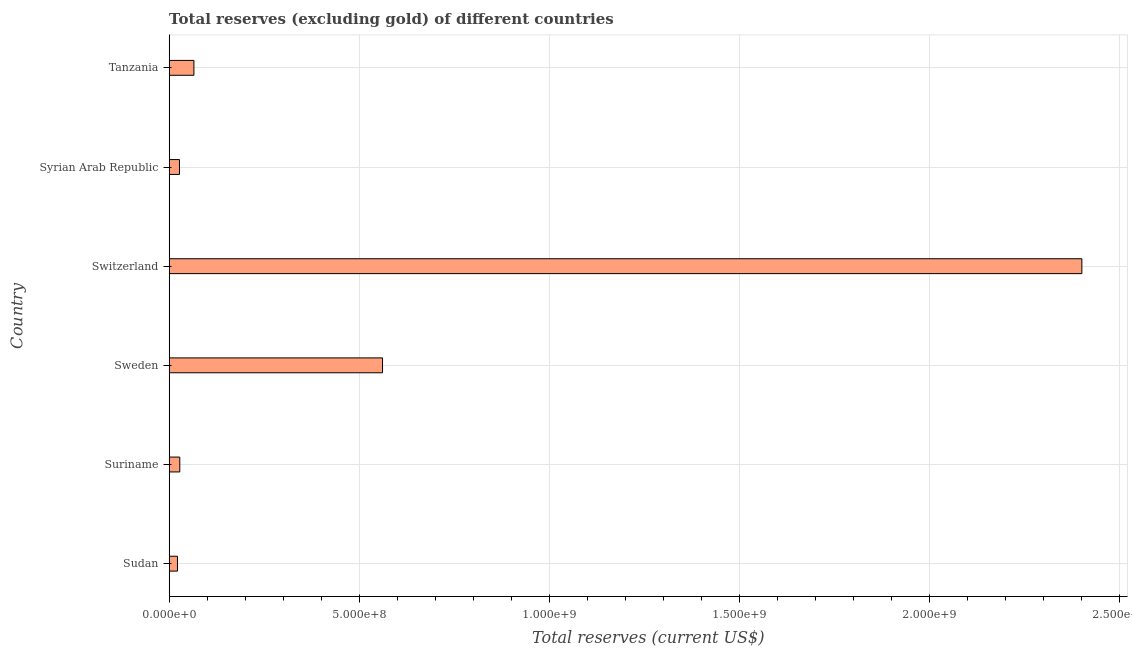Does the graph contain grids?
Provide a short and direct response. Yes. What is the title of the graph?
Offer a very short reply. Total reserves (excluding gold) of different countries. What is the label or title of the X-axis?
Your answer should be very brief. Total reserves (current US$). What is the total reserves (excluding gold) in Switzerland?
Provide a short and direct response. 2.40e+09. Across all countries, what is the maximum total reserves (excluding gold)?
Make the answer very short. 2.40e+09. Across all countries, what is the minimum total reserves (excluding gold)?
Make the answer very short. 2.17e+07. In which country was the total reserves (excluding gold) maximum?
Give a very brief answer. Switzerland. In which country was the total reserves (excluding gold) minimum?
Offer a very short reply. Sudan. What is the sum of the total reserves (excluding gold)?
Give a very brief answer. 3.10e+09. What is the difference between the total reserves (excluding gold) in Sudan and Syrian Arab Republic?
Keep it short and to the point. -5.26e+06. What is the average total reserves (excluding gold) per country?
Your answer should be very brief. 5.17e+08. What is the median total reserves (excluding gold)?
Provide a succinct answer. 4.64e+07. What is the ratio of the total reserves (excluding gold) in Suriname to that in Switzerland?
Ensure brevity in your answer.  0.01. Is the difference between the total reserves (excluding gold) in Suriname and Syrian Arab Republic greater than the difference between any two countries?
Offer a very short reply. No. What is the difference between the highest and the second highest total reserves (excluding gold)?
Provide a short and direct response. 1.84e+09. Is the sum of the total reserves (excluding gold) in Suriname and Tanzania greater than the maximum total reserves (excluding gold) across all countries?
Your answer should be compact. No. What is the difference between the highest and the lowest total reserves (excluding gold)?
Offer a terse response. 2.38e+09. Are all the bars in the graph horizontal?
Ensure brevity in your answer.  Yes. What is the difference between two consecutive major ticks on the X-axis?
Give a very brief answer. 5.00e+08. Are the values on the major ticks of X-axis written in scientific E-notation?
Keep it short and to the point. Yes. What is the Total reserves (current US$) of Sudan?
Your answer should be compact. 2.17e+07. What is the Total reserves (current US$) in Suriname?
Offer a terse response. 2.78e+07. What is the Total reserves (current US$) of Sweden?
Offer a very short reply. 5.61e+08. What is the Total reserves (current US$) of Switzerland?
Your response must be concise. 2.40e+09. What is the Total reserves (current US$) of Syrian Arab Republic?
Offer a terse response. 2.70e+07. What is the Total reserves (current US$) of Tanzania?
Make the answer very short. 6.50e+07. What is the difference between the Total reserves (current US$) in Sudan and Suriname?
Your answer should be very brief. -6.09e+06. What is the difference between the Total reserves (current US$) in Sudan and Sweden?
Make the answer very short. -5.39e+08. What is the difference between the Total reserves (current US$) in Sudan and Switzerland?
Keep it short and to the point. -2.38e+09. What is the difference between the Total reserves (current US$) in Sudan and Syrian Arab Republic?
Offer a terse response. -5.26e+06. What is the difference between the Total reserves (current US$) in Sudan and Tanzania?
Your answer should be compact. -4.32e+07. What is the difference between the Total reserves (current US$) in Suriname and Sweden?
Provide a succinct answer. -5.33e+08. What is the difference between the Total reserves (current US$) in Suriname and Switzerland?
Offer a very short reply. -2.37e+09. What is the difference between the Total reserves (current US$) in Suriname and Syrian Arab Republic?
Your answer should be compact. 8.28e+05. What is the difference between the Total reserves (current US$) in Suriname and Tanzania?
Offer a very short reply. -3.71e+07. What is the difference between the Total reserves (current US$) in Sweden and Switzerland?
Keep it short and to the point. -1.84e+09. What is the difference between the Total reserves (current US$) in Sweden and Syrian Arab Republic?
Offer a terse response. 5.34e+08. What is the difference between the Total reserves (current US$) in Sweden and Tanzania?
Ensure brevity in your answer.  4.96e+08. What is the difference between the Total reserves (current US$) in Switzerland and Syrian Arab Republic?
Give a very brief answer. 2.37e+09. What is the difference between the Total reserves (current US$) in Switzerland and Tanzania?
Ensure brevity in your answer.  2.34e+09. What is the difference between the Total reserves (current US$) in Syrian Arab Republic and Tanzania?
Your answer should be compact. -3.80e+07. What is the ratio of the Total reserves (current US$) in Sudan to that in Suriname?
Your answer should be compact. 0.78. What is the ratio of the Total reserves (current US$) in Sudan to that in Sweden?
Keep it short and to the point. 0.04. What is the ratio of the Total reserves (current US$) in Sudan to that in Switzerland?
Make the answer very short. 0.01. What is the ratio of the Total reserves (current US$) in Sudan to that in Syrian Arab Republic?
Make the answer very short. 0.81. What is the ratio of the Total reserves (current US$) in Sudan to that in Tanzania?
Make the answer very short. 0.34. What is the ratio of the Total reserves (current US$) in Suriname to that in Switzerland?
Give a very brief answer. 0.01. What is the ratio of the Total reserves (current US$) in Suriname to that in Syrian Arab Republic?
Your answer should be very brief. 1.03. What is the ratio of the Total reserves (current US$) in Suriname to that in Tanzania?
Give a very brief answer. 0.43. What is the ratio of the Total reserves (current US$) in Sweden to that in Switzerland?
Keep it short and to the point. 0.23. What is the ratio of the Total reserves (current US$) in Sweden to that in Syrian Arab Republic?
Give a very brief answer. 20.79. What is the ratio of the Total reserves (current US$) in Sweden to that in Tanzania?
Give a very brief answer. 8.64. What is the ratio of the Total reserves (current US$) in Switzerland to that in Syrian Arab Republic?
Offer a terse response. 88.93. What is the ratio of the Total reserves (current US$) in Switzerland to that in Tanzania?
Keep it short and to the point. 36.96. What is the ratio of the Total reserves (current US$) in Syrian Arab Republic to that in Tanzania?
Provide a short and direct response. 0.42. 